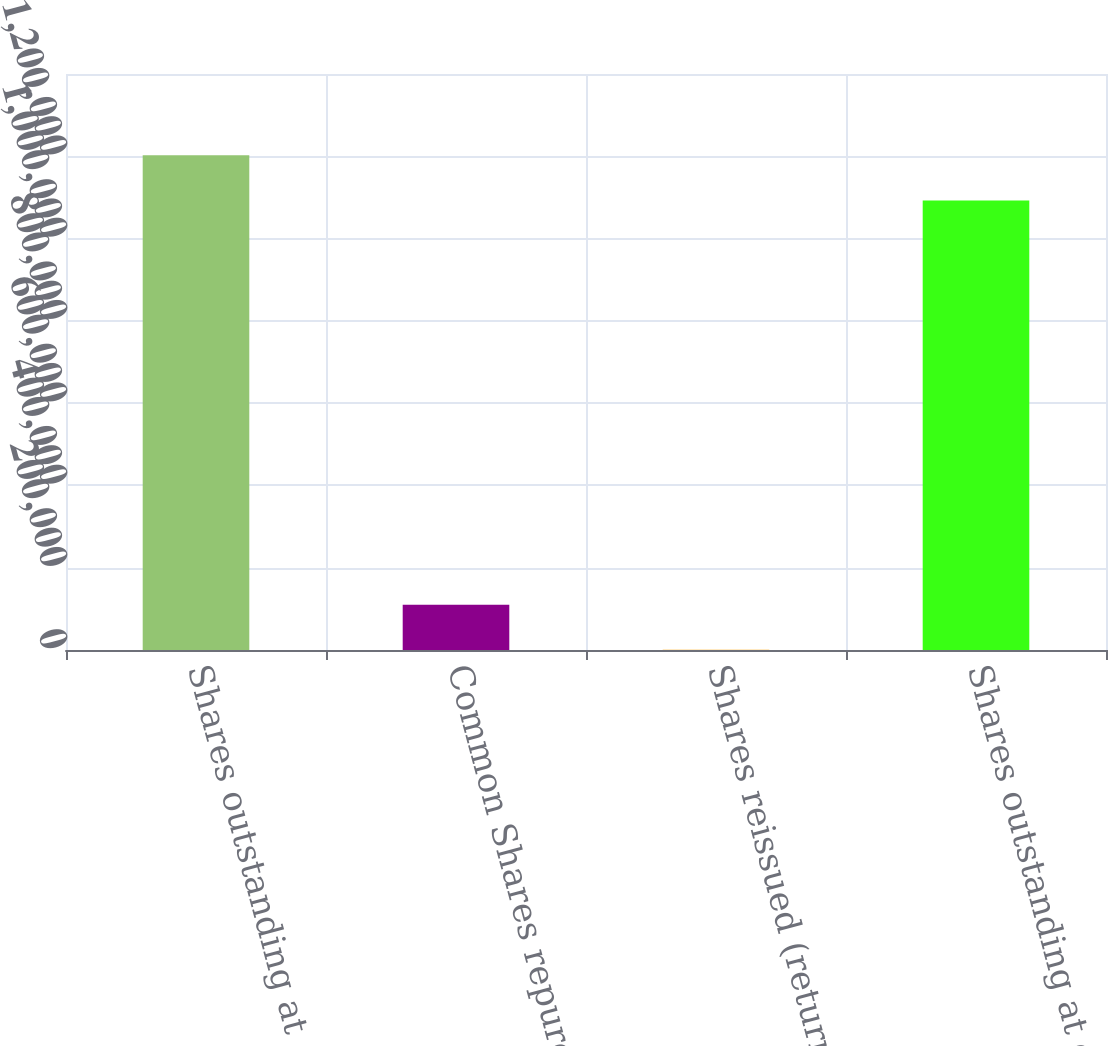Convert chart to OTSL. <chart><loc_0><loc_0><loc_500><loc_500><bar_chart><fcel>Shares outstanding at<fcel>Common Shares repurchased<fcel>Shares reissued (returned)<fcel>Shares outstanding at end of<nl><fcel>1.20245e+06<fcel>110047<fcel>332<fcel>1.09274e+06<nl></chart> 